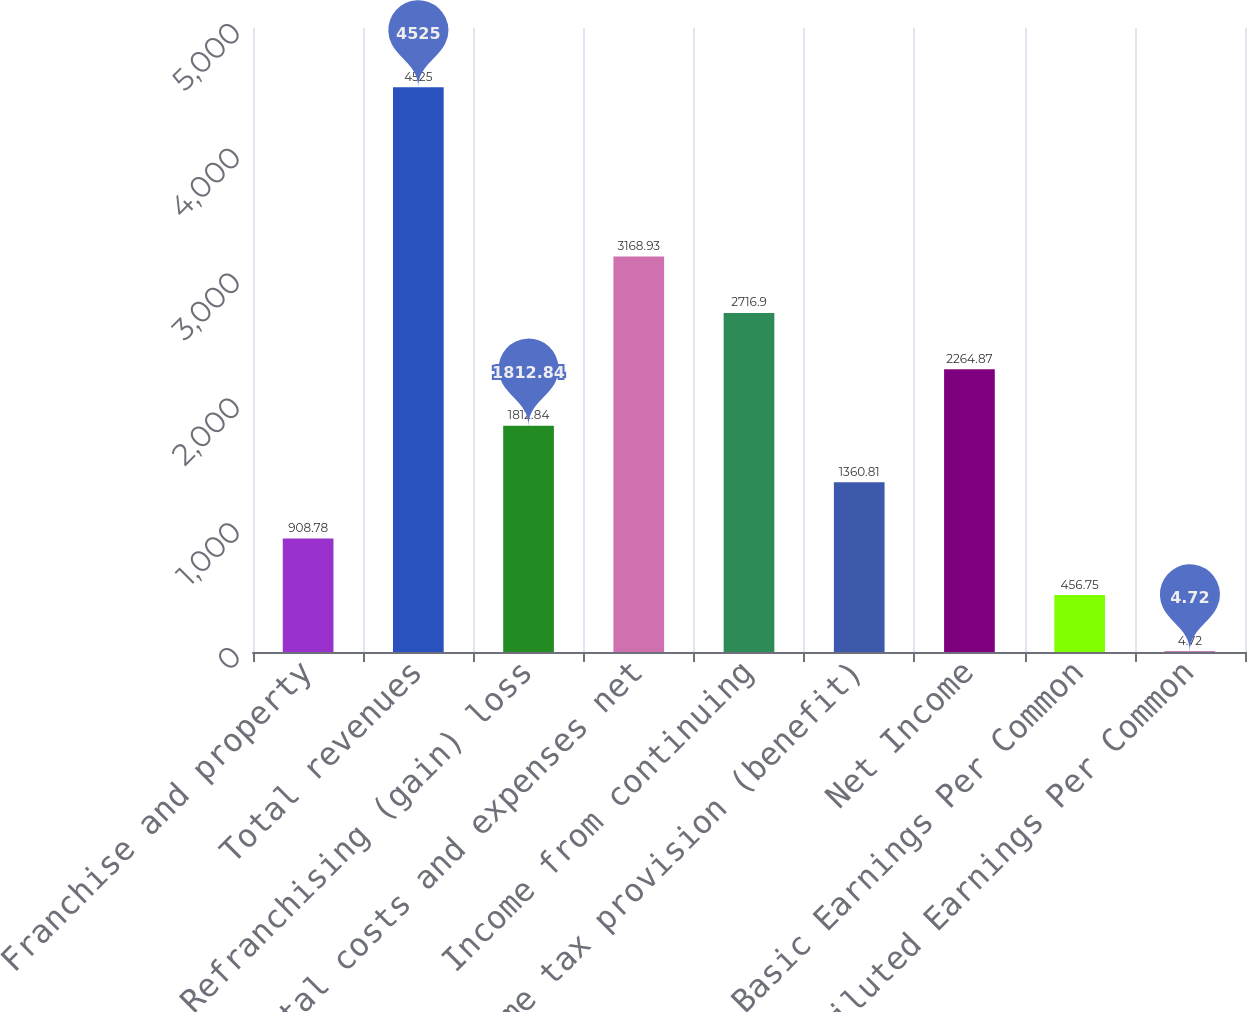Convert chart to OTSL. <chart><loc_0><loc_0><loc_500><loc_500><bar_chart><fcel>Franchise and property<fcel>Total revenues<fcel>Refranchising (gain) loss<fcel>Total costs and expenses net<fcel>Income from continuing<fcel>Income tax provision (benefit)<fcel>Net Income<fcel>Basic Earnings Per Common<fcel>Diluted Earnings Per Common<nl><fcel>908.78<fcel>4525<fcel>1812.84<fcel>3168.93<fcel>2716.9<fcel>1360.81<fcel>2264.87<fcel>456.75<fcel>4.72<nl></chart> 